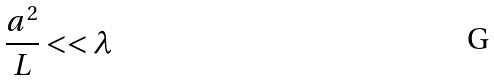<formula> <loc_0><loc_0><loc_500><loc_500>\frac { a ^ { 2 } } { L } < < \lambda</formula> 